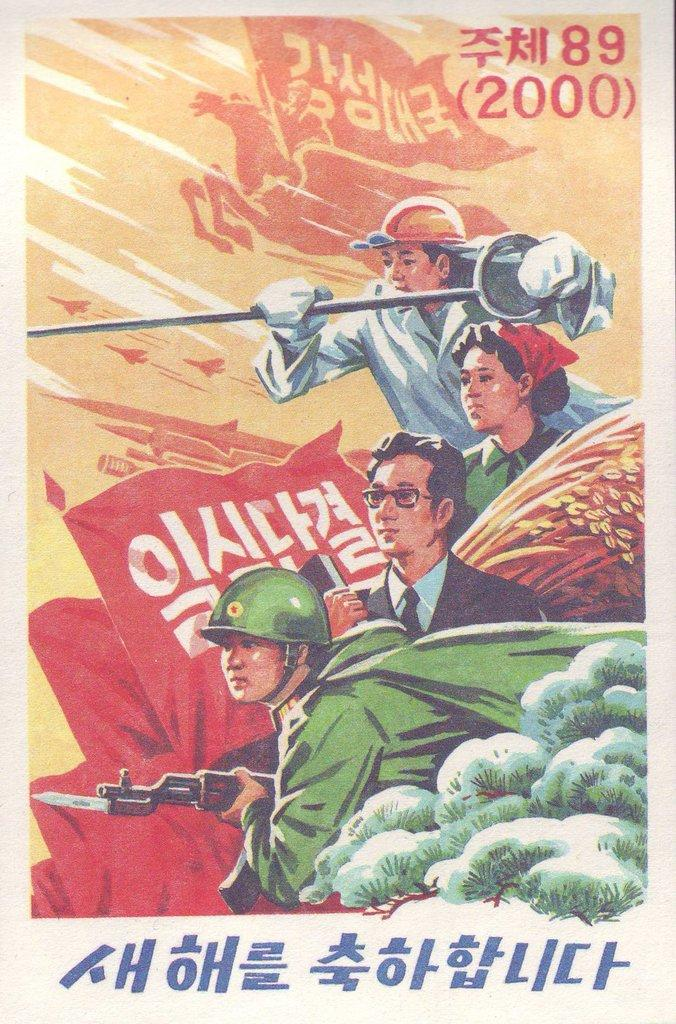<image>
Create a compact narrative representing the image presented. The number 2000 prominently stands out in the illustration depicting different careers.. 